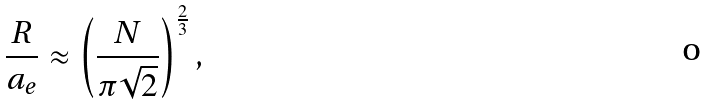Convert formula to latex. <formula><loc_0><loc_0><loc_500><loc_500>\frac { R } { a _ { e } } \approx \left ( \frac { N } { \pi \sqrt { 2 } } \right ) ^ { \frac { 2 } { 3 } } ,</formula> 